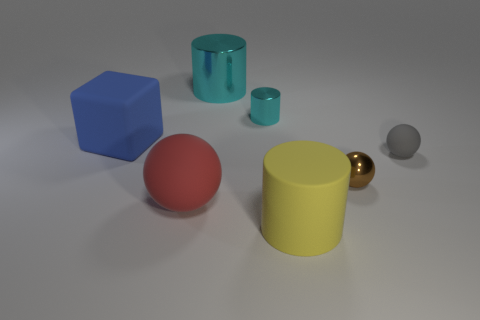Add 1 big green rubber cylinders. How many objects exist? 8 Subtract all balls. How many objects are left? 4 Subtract 1 yellow cylinders. How many objects are left? 6 Subtract all big objects. Subtract all gray rubber things. How many objects are left? 2 Add 2 brown balls. How many brown balls are left? 3 Add 3 big brown balls. How many big brown balls exist? 3 